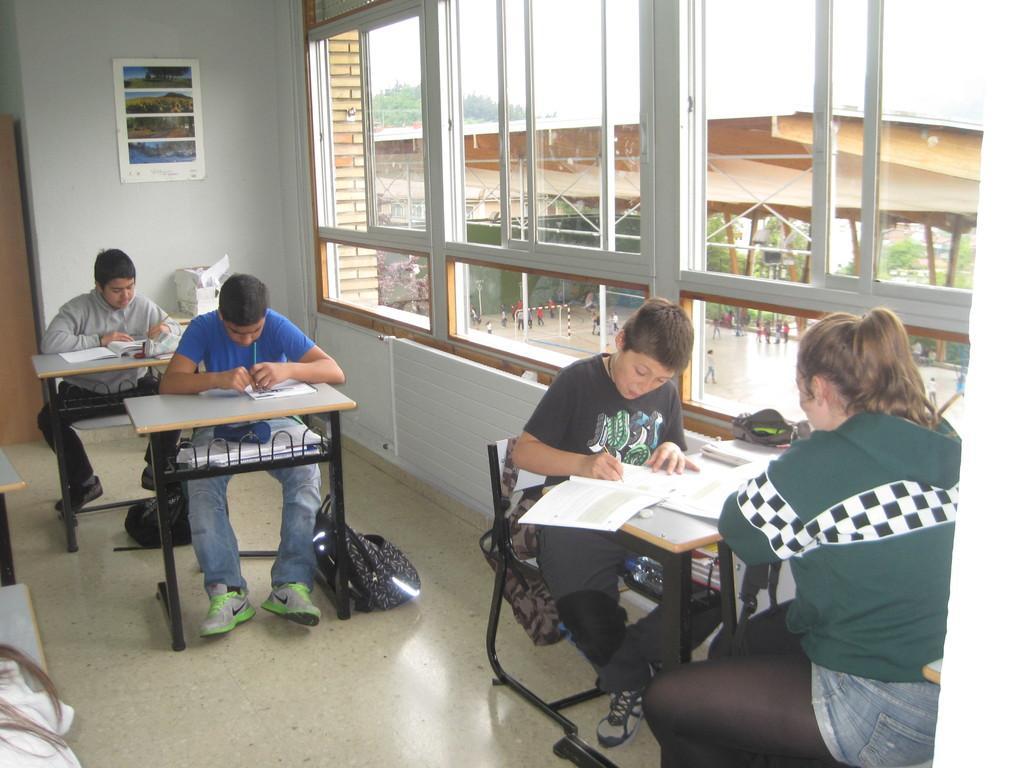Can you describe this image briefly? On the right hand side of the image, there are two persons sitting and writing on the books which are on the table.. Beside them, there are two other sitting and writing on the books which are on the pads. In the background, there is a wall, poster, window made up with glass, a ground, some persons, sky and trees. 